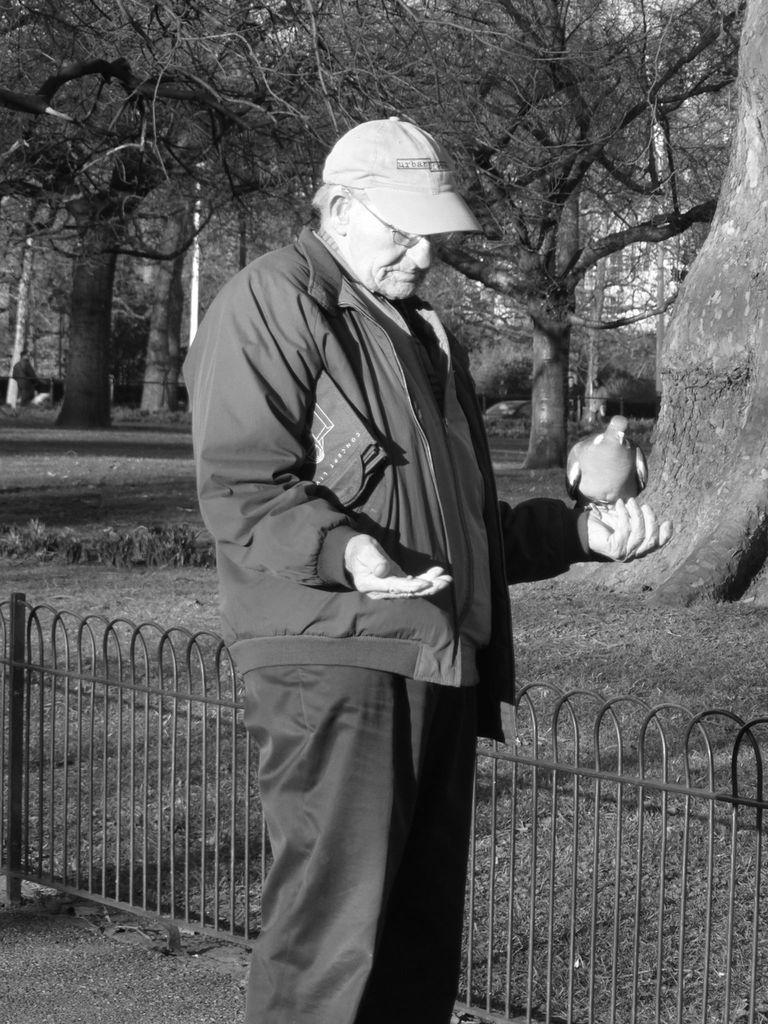What is the man in the image doing? There is a man standing in the image, and a bird is on his hand. What is the man wearing on his head? The man is wearing a cap on his head. What can be seen in the background of the image? Trees are visible in the background of the image. What is present near the man in the image? A: There is a metal fence in the image. What type of boat is the man using to teach education in the image? There is no boat or education-related activity depicted in the image. The man is simply standing with a bird on his hand, wearing a cap, and near a metal fence with trees in the background. 